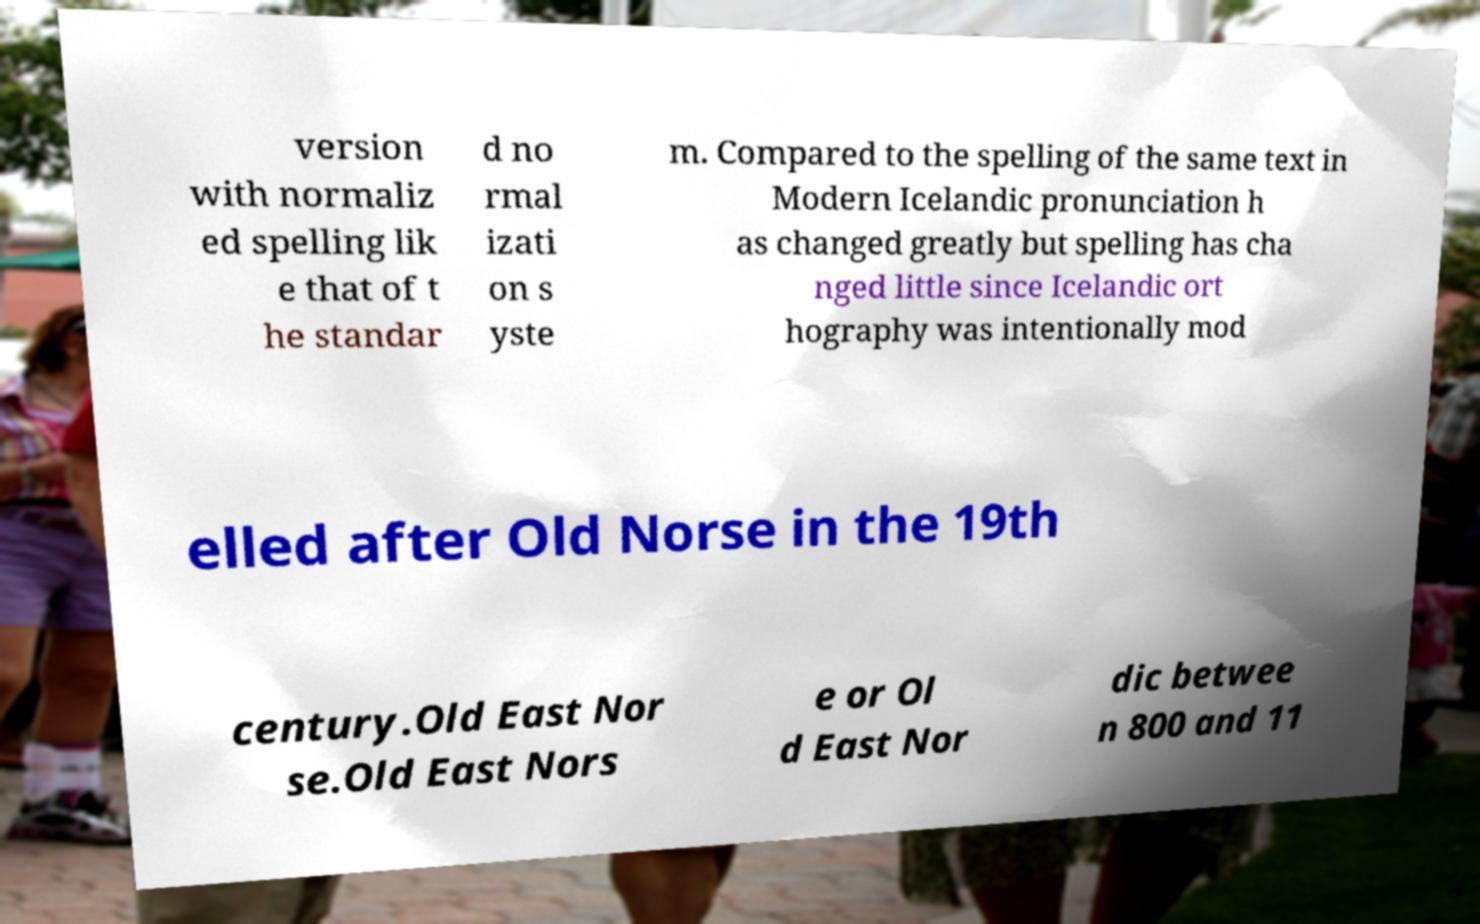Can you accurately transcribe the text from the provided image for me? version with normaliz ed spelling lik e that of t he standar d no rmal izati on s yste m. Compared to the spelling of the same text in Modern Icelandic pronunciation h as changed greatly but spelling has cha nged little since Icelandic ort hography was intentionally mod elled after Old Norse in the 19th century.Old East Nor se.Old East Nors e or Ol d East Nor dic betwee n 800 and 11 